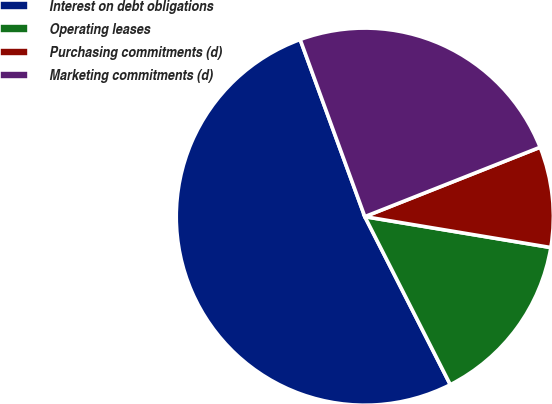<chart> <loc_0><loc_0><loc_500><loc_500><pie_chart><fcel>Interest on debt obligations<fcel>Operating leases<fcel>Purchasing commitments (d)<fcel>Marketing commitments (d)<nl><fcel>51.92%<fcel>14.89%<fcel>8.62%<fcel>24.57%<nl></chart> 